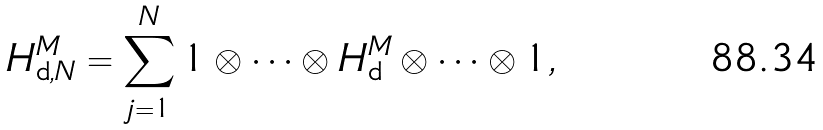Convert formula to latex. <formula><loc_0><loc_0><loc_500><loc_500>H ^ { M } _ { \text {d} , N } = \sum _ { j = 1 } ^ { N } 1 \otimes \cdots \otimes H ^ { M } _ { \text {d} } \otimes \cdots \otimes 1 ,</formula> 